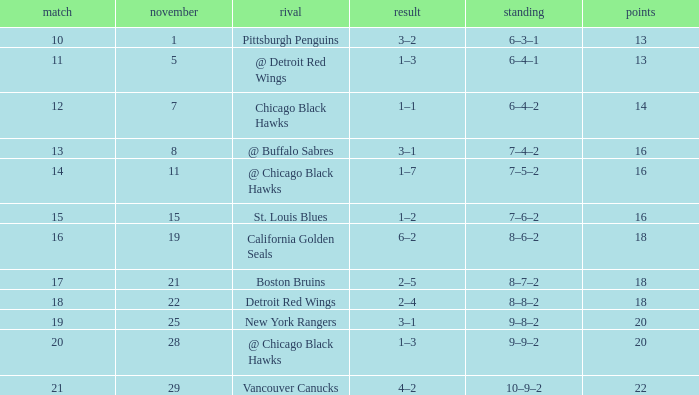Which opponent has points less than 18, and a november greater than 11? St. Louis Blues. 